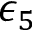Convert formula to latex. <formula><loc_0><loc_0><loc_500><loc_500>\epsilon _ { 5 }</formula> 